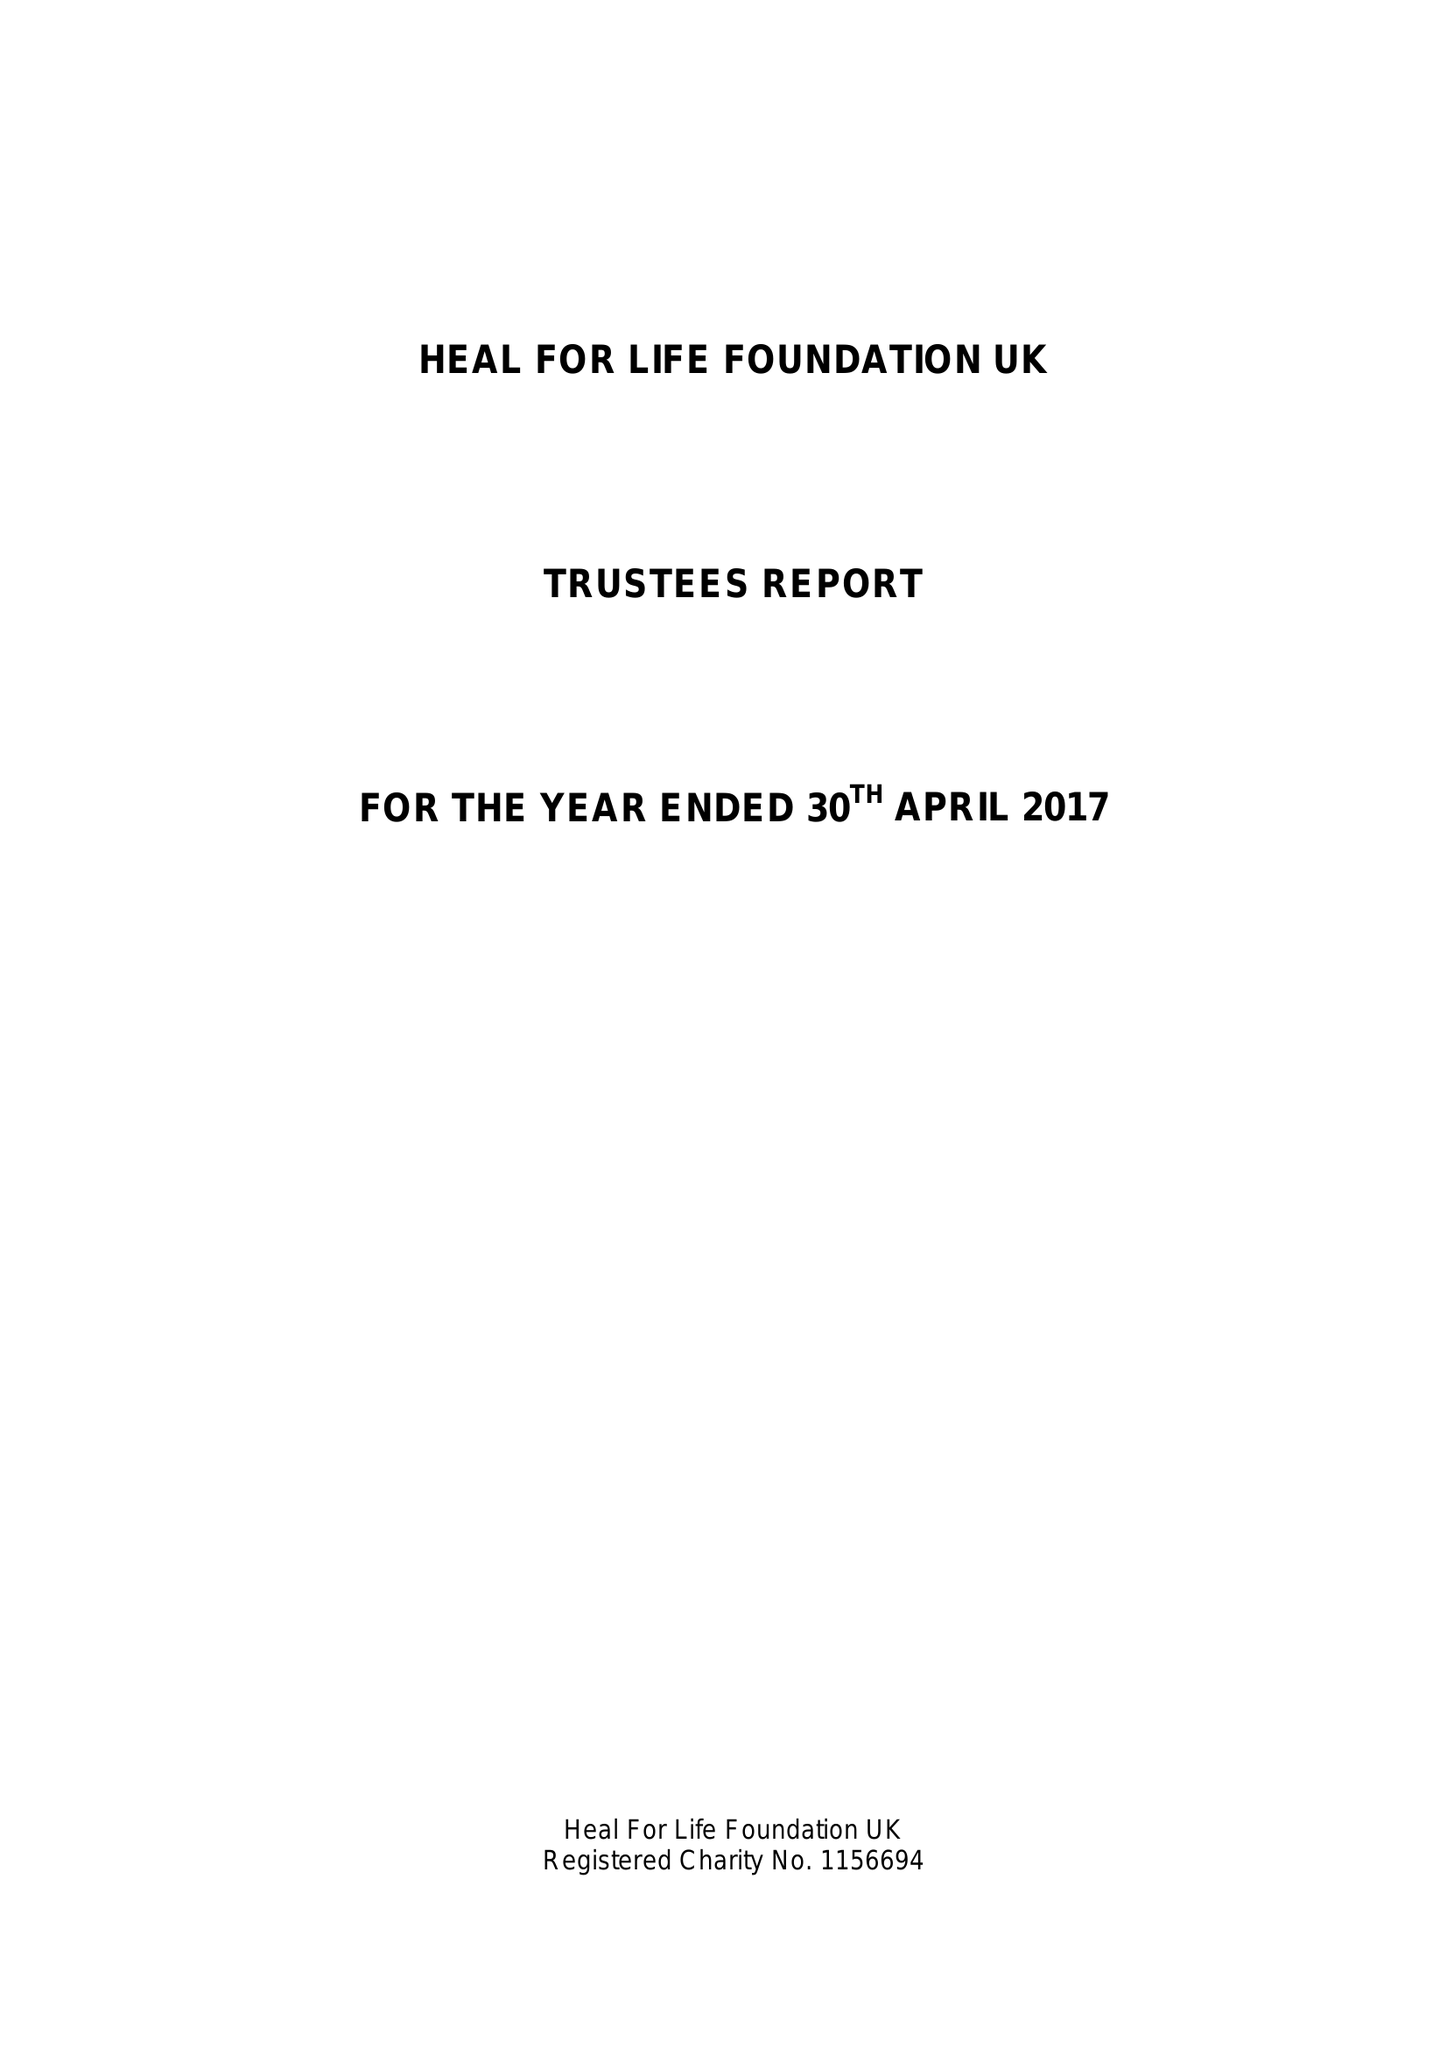What is the value for the address__postcode?
Answer the question using a single word or phrase. TN25 5BJ 